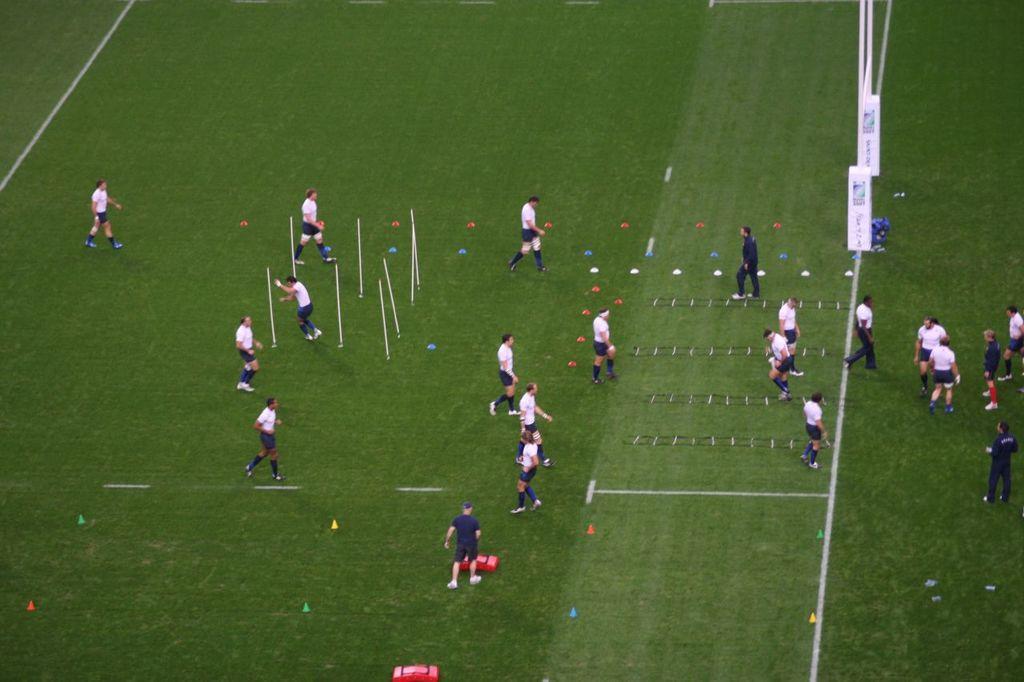How would you summarize this image in a sentence or two? In this image, there are group of people standing and wearing clothes. 